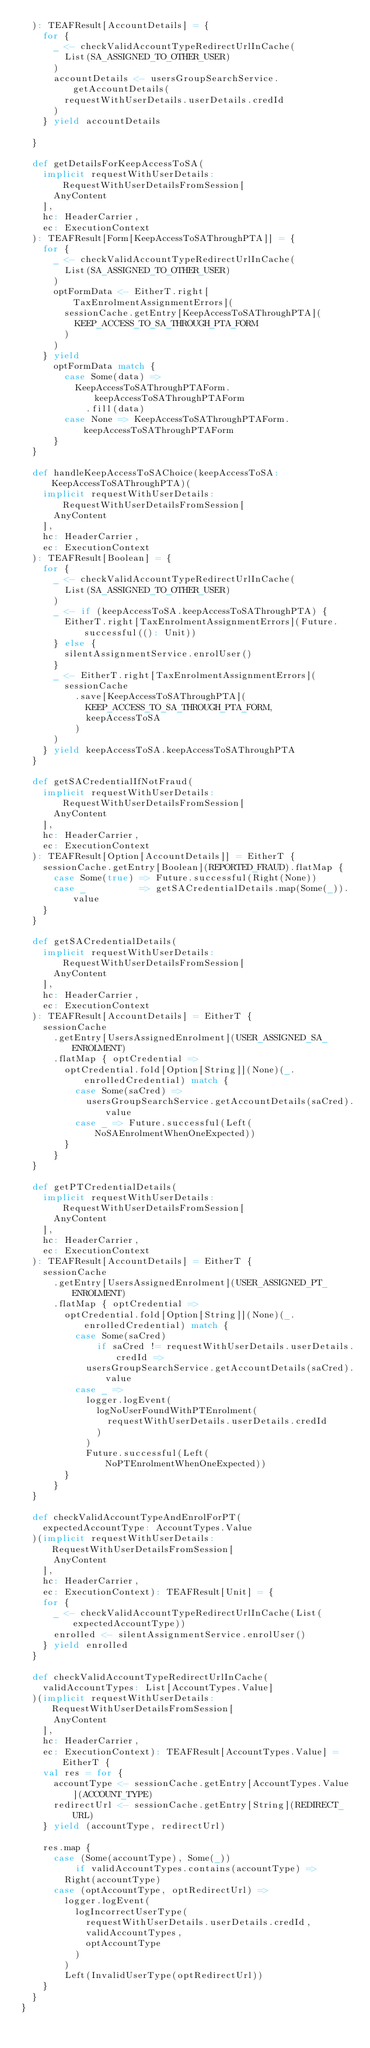Convert code to text. <code><loc_0><loc_0><loc_500><loc_500><_Scala_>  ): TEAFResult[AccountDetails] = {
    for {
      _ <- checkValidAccountTypeRedirectUrlInCache(
        List(SA_ASSIGNED_TO_OTHER_USER)
      )
      accountDetails <- usersGroupSearchService.getAccountDetails(
        requestWithUserDetails.userDetails.credId
      )
    } yield accountDetails

  }

  def getDetailsForKeepAccessToSA(
    implicit requestWithUserDetails: RequestWithUserDetailsFromSession[
      AnyContent
    ],
    hc: HeaderCarrier,
    ec: ExecutionContext
  ): TEAFResult[Form[KeepAccessToSAThroughPTA]] = {
    for {
      _ <- checkValidAccountTypeRedirectUrlInCache(
        List(SA_ASSIGNED_TO_OTHER_USER)
      )
      optFormData <- EitherT.right[TaxEnrolmentAssignmentErrors](
        sessionCache.getEntry[KeepAccessToSAThroughPTA](
          KEEP_ACCESS_TO_SA_THROUGH_PTA_FORM
        )
      )
    } yield
      optFormData match {
        case Some(data) =>
          KeepAccessToSAThroughPTAForm.keepAccessToSAThroughPTAForm
            .fill(data)
        case None => KeepAccessToSAThroughPTAForm.keepAccessToSAThroughPTAForm
      }
  }

  def handleKeepAccessToSAChoice(keepAccessToSA: KeepAccessToSAThroughPTA)(
    implicit requestWithUserDetails: RequestWithUserDetailsFromSession[
      AnyContent
    ],
    hc: HeaderCarrier,
    ec: ExecutionContext
  ): TEAFResult[Boolean] = {
    for {
      _ <- checkValidAccountTypeRedirectUrlInCache(
        List(SA_ASSIGNED_TO_OTHER_USER)
      )
      _ <- if (keepAccessToSA.keepAccessToSAThroughPTA) {
        EitherT.right[TaxEnrolmentAssignmentErrors](Future.successful((): Unit))
      } else {
        silentAssignmentService.enrolUser()
      }
      _ <- EitherT.right[TaxEnrolmentAssignmentErrors](
        sessionCache
          .save[KeepAccessToSAThroughPTA](
            KEEP_ACCESS_TO_SA_THROUGH_PTA_FORM,
            keepAccessToSA
          )
      )
    } yield keepAccessToSA.keepAccessToSAThroughPTA
  }

  def getSACredentialIfNotFraud(
    implicit requestWithUserDetails: RequestWithUserDetailsFromSession[
      AnyContent
    ],
    hc: HeaderCarrier,
    ec: ExecutionContext
  ): TEAFResult[Option[AccountDetails]] = EitherT {
    sessionCache.getEntry[Boolean](REPORTED_FRAUD).flatMap {
      case Some(true) => Future.successful(Right(None))
      case _          => getSACredentialDetails.map(Some(_)).value
    }
  }

  def getSACredentialDetails(
    implicit requestWithUserDetails: RequestWithUserDetailsFromSession[
      AnyContent
    ],
    hc: HeaderCarrier,
    ec: ExecutionContext
  ): TEAFResult[AccountDetails] = EitherT {
    sessionCache
      .getEntry[UsersAssignedEnrolment](USER_ASSIGNED_SA_ENROLMENT)
      .flatMap { optCredential =>
        optCredential.fold[Option[String]](None)(_.enrolledCredential) match {
          case Some(saCred) =>
            usersGroupSearchService.getAccountDetails(saCred).value
          case _ => Future.successful(Left(NoSAEnrolmentWhenOneExpected))
        }
      }
  }

  def getPTCredentialDetails(
    implicit requestWithUserDetails: RequestWithUserDetailsFromSession[
      AnyContent
    ],
    hc: HeaderCarrier,
    ec: ExecutionContext
  ): TEAFResult[AccountDetails] = EitherT {
    sessionCache
      .getEntry[UsersAssignedEnrolment](USER_ASSIGNED_PT_ENROLMENT)
      .flatMap { optCredential =>
        optCredential.fold[Option[String]](None)(_.enrolledCredential) match {
          case Some(saCred)
              if saCred != requestWithUserDetails.userDetails.credId =>
            usersGroupSearchService.getAccountDetails(saCred).value
          case _ =>
            logger.logEvent(
              logNoUserFoundWithPTEnrolment(
                requestWithUserDetails.userDetails.credId
              )
            )
            Future.successful(Left(NoPTEnrolmentWhenOneExpected))
        }
      }
  }

  def checkValidAccountTypeAndEnrolForPT(
    expectedAccountType: AccountTypes.Value
  )(implicit requestWithUserDetails: RequestWithUserDetailsFromSession[
      AnyContent
    ],
    hc: HeaderCarrier,
    ec: ExecutionContext): TEAFResult[Unit] = {
    for {
      _ <- checkValidAccountTypeRedirectUrlInCache(List(expectedAccountType))
      enrolled <- silentAssignmentService.enrolUser()
    } yield enrolled
  }

  def checkValidAccountTypeRedirectUrlInCache(
    validAccountTypes: List[AccountTypes.Value]
  )(implicit requestWithUserDetails: RequestWithUserDetailsFromSession[
      AnyContent
    ],
    hc: HeaderCarrier,
    ec: ExecutionContext): TEAFResult[AccountTypes.Value] = EitherT {
    val res = for {
      accountType <- sessionCache.getEntry[AccountTypes.Value](ACCOUNT_TYPE)
      redirectUrl <- sessionCache.getEntry[String](REDIRECT_URL)
    } yield (accountType, redirectUrl)

    res.map {
      case (Some(accountType), Some(_))
          if validAccountTypes.contains(accountType) =>
        Right(accountType)
      case (optAccountType, optRedirectUrl) =>
        logger.logEvent(
          logIncorrectUserType(
            requestWithUserDetails.userDetails.credId,
            validAccountTypes,
            optAccountType
          )
        )
        Left(InvalidUserType(optRedirectUrl))
    }
  }
}
</code> 